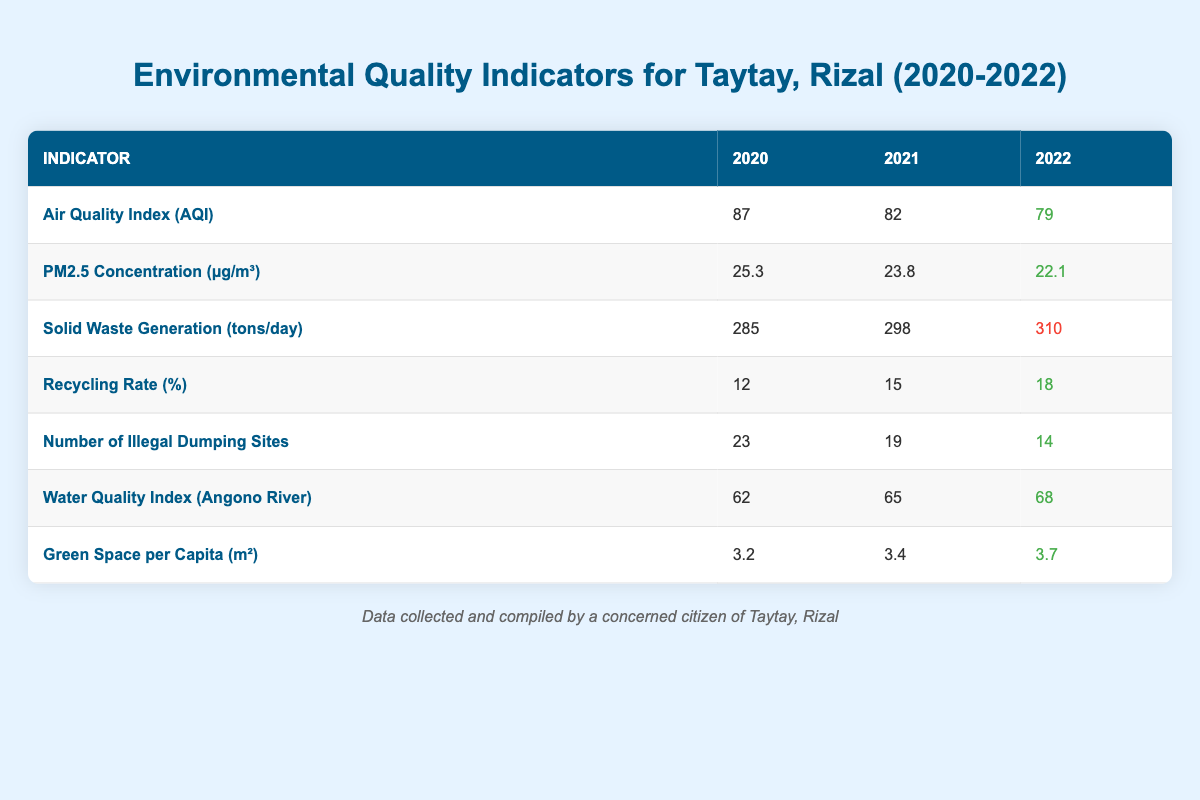What was the Air Quality Index (AQI) in Taytay, Rizal for 2022? The table indicates that the AQI for 2022 is listed under the column for that year, which shows a value of 79.
Answer: 79 How many illegal dumping sites were reported in 2021? Referring to the table, the number of illegal dumping sites for 2021 is directly provided in the respective row, which is 19.
Answer: 19 What is the trend in the PM2.5 concentration from 2020 to 2022? By examining the values for PM2.5 concentration, which are 25.3 in 2020, 23.8 in 2021, and 22.1 in 2022, we can see a consistent decrease each year, indicating an improving trend.
Answer: Decreasing What is the total solid waste generation in Taytay, Rizal from 2020 to 2022? To find the total solid waste generation, we can sum the values from each year: 285 (2020) + 298 (2021) + 310 (2022) = 893 tons/day.
Answer: 893 Did the recycling rate improve from 2021 to 2022? By comparing the rates, the recycling rate was 15% in 2021 and increased to 18% in 2022, indicating that yes, there was an improvement.
Answer: Yes What was the percentage increase in recycling rate from 2020 to 2022? The recycling rates for those years are 12% (2020) and 18% (2022). The increase is calculated as (18 - 12) / 12 * 100%, which equals 50%.
Answer: 50% Is the water quality in the Angono River improving over the years? The table shows a steady increase in the Water Quality Index, with values of 62 (2020), 65 (2021), and 68 (2022), confirming that the water quality is improving.
Answer: Yes What is the average green space per capita from 2020 to 2022? To find the average, add the values of green space per capita for three years: (3.2 + 3.4 + 3.7) / 3 = 3.433 m², which can be rounded to two decimal places if needed.
Answer: 3.43 What was the change in the number of illegal dumping sites from 2020 to 2022? The number dropped from 23 in 2020 to 14 in 2022. The decrease is 23 - 14 = 9 sites, indicating significant progress in waste management.
Answer: Decrease of 9 sites 